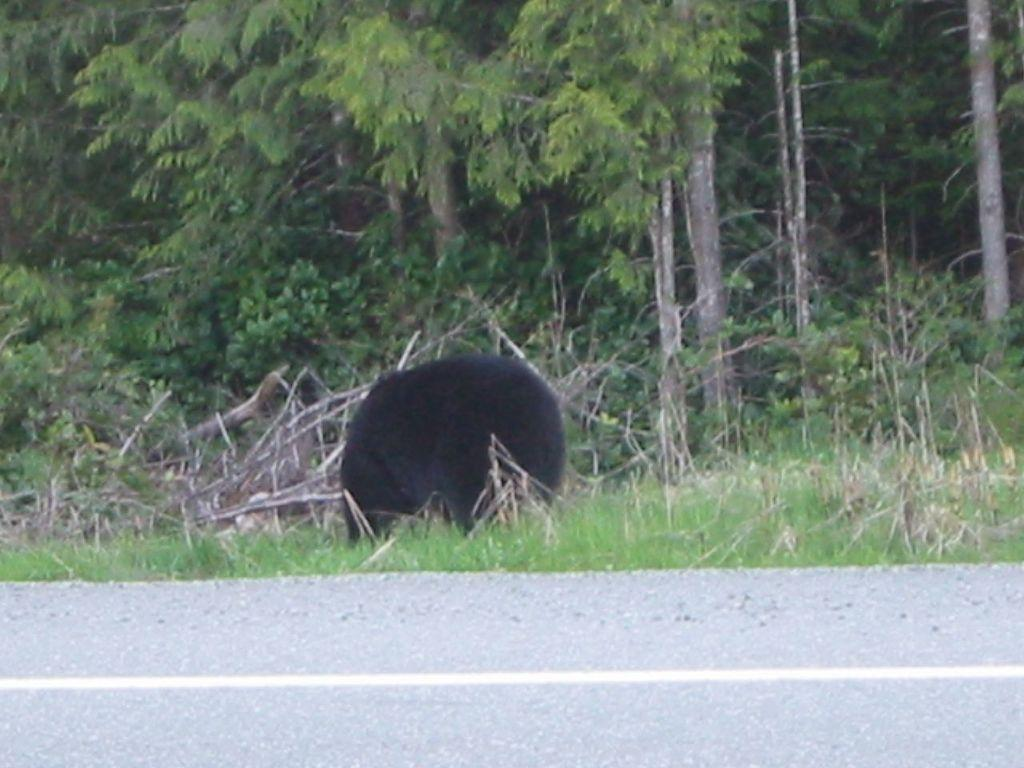What animal is present in the image? There is a bear in the image. What is the bear doing in the image? The bear is standing. What type of terrain is visible at the bottom of the image? There is grass at the bottom of the image. What can be seen in the background of the image? There are trees in the background of the image. What type of man-made structure is visible in the image? There is a road in the image. What type of attraction is the bear performing at the club in the image? There is no attraction or club present in the image; it features a bear standing on grass with trees in the background and a road visible. 